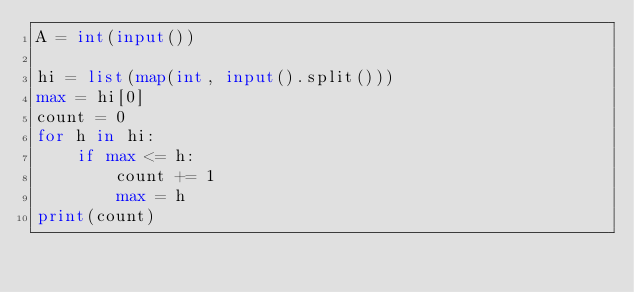<code> <loc_0><loc_0><loc_500><loc_500><_Python_>A = int(input())

hi = list(map(int, input().split()))
max = hi[0]
count = 0
for h in hi:
    if max <= h:
        count += 1
        max = h
print(count)</code> 